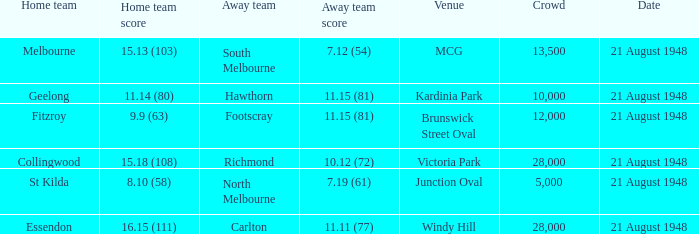When the Home team score was 15.18 (108), what's the lowest Crowd turnout? 28000.0. 